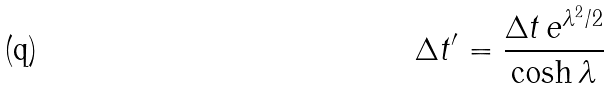<formula> <loc_0><loc_0><loc_500><loc_500>\Delta t ^ { \prime } = \frac { \Delta t \, e ^ { \lambda ^ { 2 } / 2 } } { \cosh { \lambda } }</formula> 